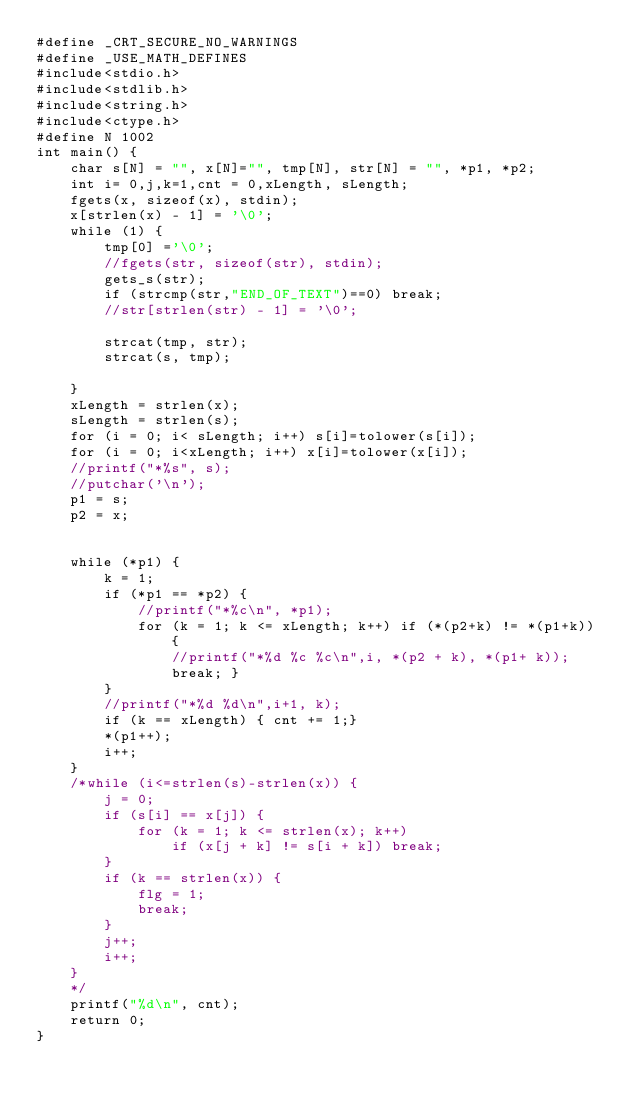Convert code to text. <code><loc_0><loc_0><loc_500><loc_500><_C_>#define _CRT_SECURE_NO_WARNINGS
#define _USE_MATH_DEFINES
#include<stdio.h>
#include<stdlib.h>
#include<string.h>
#include<ctype.h>
#define N 1002
int main() {
	char s[N] = "", x[N]="", tmp[N], str[N] = "", *p1, *p2;
	int i= 0,j,k=1,cnt = 0,xLength, sLength;
	fgets(x, sizeof(x), stdin);
	x[strlen(x) - 1] = '\0';
	while (1) {
		tmp[0] ='\0';
		//fgets(str, sizeof(str), stdin);
		gets_s(str);
		if (strcmp(str,"END_OF_TEXT")==0) break;
		//str[strlen(str) - 1] = '\0';
		
		strcat(tmp, str);
		strcat(s, tmp);
		
	}
	xLength = strlen(x);
	sLength = strlen(s);
	for (i = 0; i< sLength; i++) s[i]=tolower(s[i]);
	for (i = 0; i<xLength; i++) x[i]=tolower(x[i]);
	//printf("*%s", s);
	//putchar('\n');
	p1 = s;
	p2 = x;
	

	while (*p1) {
		k = 1;
		if (*p1 == *p2) {
			//printf("*%c\n", *p1);
			for (k = 1; k <= xLength; k++) if (*(p2+k) != *(p1+k)) { 
				//printf("*%d %c %c\n",i, *(p2 + k), *(p1+ k)); 
				break; }
		}
		//printf("*%d %d\n",i+1, k);
		if (k == xLength) { cnt += 1;}
		*(p1++);
		i++;
	}
	/*while (i<=strlen(s)-strlen(x)) {
		j = 0;
		if (s[i] == x[j]) {
			for (k = 1; k <= strlen(x); k++)
				if (x[j + k] != s[i + k]) break;
		}
		if (k == strlen(x)) {
			flg = 1;
			break;
		}
		j++;
		i++;
	}
	*/
	printf("%d\n", cnt);
	return 0;
}</code> 